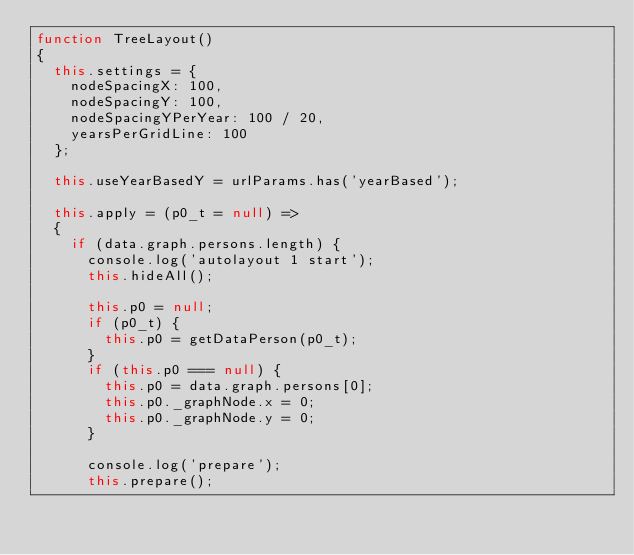<code> <loc_0><loc_0><loc_500><loc_500><_JavaScript_>function TreeLayout()
{
  this.settings = {
    nodeSpacingX: 100,
    nodeSpacingY: 100,
    nodeSpacingYPerYear: 100 / 20,
    yearsPerGridLine: 100
  };

  this.useYearBasedY = urlParams.has('yearBased');

  this.apply = (p0_t = null) =>
  {
    if (data.graph.persons.length) {
      console.log('autolayout 1 start');
      this.hideAll();

      this.p0 = null;
      if (p0_t) {
        this.p0 = getDataPerson(p0_t);
      }
      if (this.p0 === null) {
        this.p0 = data.graph.persons[0];
        this.p0._graphNode.x = 0;
        this.p0._graphNode.y = 0;
      }

      console.log('prepare');
      this.prepare();
</code> 